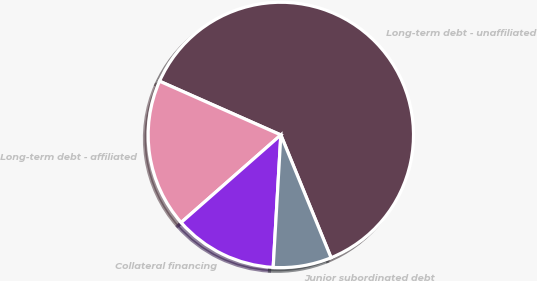<chart> <loc_0><loc_0><loc_500><loc_500><pie_chart><fcel>Long-term debt - unaffiliated<fcel>Long-term debt - affiliated<fcel>Collateral financing<fcel>Junior subordinated debt<nl><fcel>62.18%<fcel>18.11%<fcel>12.61%<fcel>7.1%<nl></chart> 